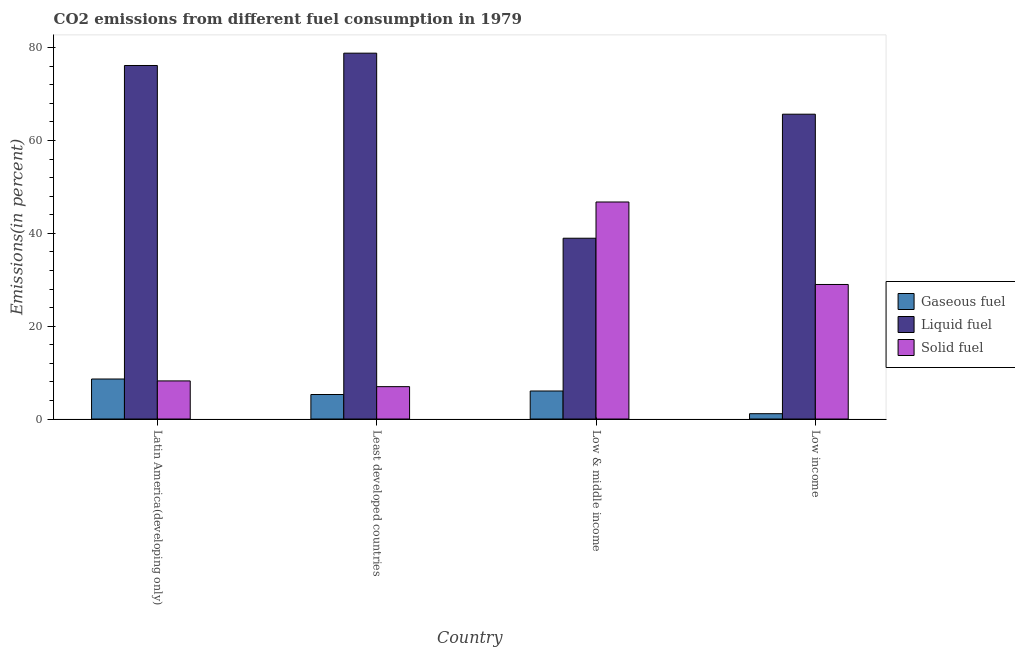How many different coloured bars are there?
Your answer should be compact. 3. How many bars are there on the 1st tick from the left?
Provide a short and direct response. 3. What is the label of the 3rd group of bars from the left?
Your answer should be compact. Low & middle income. In how many cases, is the number of bars for a given country not equal to the number of legend labels?
Keep it short and to the point. 0. What is the percentage of solid fuel emission in Low & middle income?
Your answer should be very brief. 46.75. Across all countries, what is the maximum percentage of gaseous fuel emission?
Make the answer very short. 8.62. Across all countries, what is the minimum percentage of gaseous fuel emission?
Offer a terse response. 1.15. In which country was the percentage of gaseous fuel emission maximum?
Provide a short and direct response. Latin America(developing only). What is the total percentage of gaseous fuel emission in the graph?
Your response must be concise. 21.08. What is the difference between the percentage of liquid fuel emission in Latin America(developing only) and that in Low & middle income?
Keep it short and to the point. 37.21. What is the difference between the percentage of solid fuel emission in Low income and the percentage of liquid fuel emission in Least developed countries?
Ensure brevity in your answer.  -49.83. What is the average percentage of gaseous fuel emission per country?
Ensure brevity in your answer.  5.27. What is the difference between the percentage of gaseous fuel emission and percentage of liquid fuel emission in Least developed countries?
Your response must be concise. -73.54. What is the ratio of the percentage of liquid fuel emission in Latin America(developing only) to that in Low income?
Give a very brief answer. 1.16. Is the difference between the percentage of solid fuel emission in Latin America(developing only) and Least developed countries greater than the difference between the percentage of gaseous fuel emission in Latin America(developing only) and Least developed countries?
Provide a short and direct response. No. What is the difference between the highest and the second highest percentage of liquid fuel emission?
Your answer should be very brief. 2.65. What is the difference between the highest and the lowest percentage of solid fuel emission?
Provide a short and direct response. 39.78. Is the sum of the percentage of liquid fuel emission in Latin America(developing only) and Least developed countries greater than the maximum percentage of gaseous fuel emission across all countries?
Your answer should be very brief. Yes. What does the 2nd bar from the left in Low income represents?
Your answer should be compact. Liquid fuel. What does the 1st bar from the right in Least developed countries represents?
Your response must be concise. Solid fuel. Is it the case that in every country, the sum of the percentage of gaseous fuel emission and percentage of liquid fuel emission is greater than the percentage of solid fuel emission?
Give a very brief answer. No. Are all the bars in the graph horizontal?
Your answer should be compact. No. How many countries are there in the graph?
Ensure brevity in your answer.  4. Where does the legend appear in the graph?
Your answer should be compact. Center right. How are the legend labels stacked?
Provide a short and direct response. Vertical. What is the title of the graph?
Give a very brief answer. CO2 emissions from different fuel consumption in 1979. Does "Communicable diseases" appear as one of the legend labels in the graph?
Your answer should be very brief. No. What is the label or title of the Y-axis?
Offer a terse response. Emissions(in percent). What is the Emissions(in percent) of Gaseous fuel in Latin America(developing only)?
Give a very brief answer. 8.62. What is the Emissions(in percent) in Liquid fuel in Latin America(developing only)?
Provide a succinct answer. 76.16. What is the Emissions(in percent) in Solid fuel in Latin America(developing only)?
Your response must be concise. 8.21. What is the Emissions(in percent) in Gaseous fuel in Least developed countries?
Provide a short and direct response. 5.28. What is the Emissions(in percent) of Liquid fuel in Least developed countries?
Provide a short and direct response. 78.81. What is the Emissions(in percent) of Solid fuel in Least developed countries?
Provide a succinct answer. 6.97. What is the Emissions(in percent) of Gaseous fuel in Low & middle income?
Provide a succinct answer. 6.04. What is the Emissions(in percent) of Liquid fuel in Low & middle income?
Provide a short and direct response. 38.95. What is the Emissions(in percent) of Solid fuel in Low & middle income?
Offer a terse response. 46.75. What is the Emissions(in percent) of Gaseous fuel in Low income?
Offer a terse response. 1.15. What is the Emissions(in percent) in Liquid fuel in Low income?
Provide a succinct answer. 65.67. What is the Emissions(in percent) in Solid fuel in Low income?
Offer a terse response. 28.98. Across all countries, what is the maximum Emissions(in percent) in Gaseous fuel?
Keep it short and to the point. 8.62. Across all countries, what is the maximum Emissions(in percent) in Liquid fuel?
Give a very brief answer. 78.81. Across all countries, what is the maximum Emissions(in percent) of Solid fuel?
Your response must be concise. 46.75. Across all countries, what is the minimum Emissions(in percent) in Gaseous fuel?
Provide a short and direct response. 1.15. Across all countries, what is the minimum Emissions(in percent) in Liquid fuel?
Your answer should be very brief. 38.95. Across all countries, what is the minimum Emissions(in percent) of Solid fuel?
Provide a succinct answer. 6.97. What is the total Emissions(in percent) in Gaseous fuel in the graph?
Provide a short and direct response. 21.08. What is the total Emissions(in percent) in Liquid fuel in the graph?
Provide a short and direct response. 259.59. What is the total Emissions(in percent) in Solid fuel in the graph?
Provide a short and direct response. 90.92. What is the difference between the Emissions(in percent) in Gaseous fuel in Latin America(developing only) and that in Least developed countries?
Keep it short and to the point. 3.34. What is the difference between the Emissions(in percent) in Liquid fuel in Latin America(developing only) and that in Least developed countries?
Your answer should be compact. -2.65. What is the difference between the Emissions(in percent) in Solid fuel in Latin America(developing only) and that in Least developed countries?
Offer a terse response. 1.24. What is the difference between the Emissions(in percent) in Gaseous fuel in Latin America(developing only) and that in Low & middle income?
Keep it short and to the point. 2.58. What is the difference between the Emissions(in percent) in Liquid fuel in Latin America(developing only) and that in Low & middle income?
Provide a short and direct response. 37.21. What is the difference between the Emissions(in percent) of Solid fuel in Latin America(developing only) and that in Low & middle income?
Ensure brevity in your answer.  -38.55. What is the difference between the Emissions(in percent) in Gaseous fuel in Latin America(developing only) and that in Low income?
Your answer should be compact. 7.47. What is the difference between the Emissions(in percent) of Liquid fuel in Latin America(developing only) and that in Low income?
Your answer should be compact. 10.49. What is the difference between the Emissions(in percent) of Solid fuel in Latin America(developing only) and that in Low income?
Keep it short and to the point. -20.77. What is the difference between the Emissions(in percent) in Gaseous fuel in Least developed countries and that in Low & middle income?
Keep it short and to the point. -0.76. What is the difference between the Emissions(in percent) of Liquid fuel in Least developed countries and that in Low & middle income?
Your answer should be compact. 39.87. What is the difference between the Emissions(in percent) in Solid fuel in Least developed countries and that in Low & middle income?
Give a very brief answer. -39.78. What is the difference between the Emissions(in percent) in Gaseous fuel in Least developed countries and that in Low income?
Your response must be concise. 4.13. What is the difference between the Emissions(in percent) in Liquid fuel in Least developed countries and that in Low income?
Your response must be concise. 13.15. What is the difference between the Emissions(in percent) in Solid fuel in Least developed countries and that in Low income?
Offer a terse response. -22.01. What is the difference between the Emissions(in percent) of Gaseous fuel in Low & middle income and that in Low income?
Make the answer very short. 4.89. What is the difference between the Emissions(in percent) in Liquid fuel in Low & middle income and that in Low income?
Give a very brief answer. -26.72. What is the difference between the Emissions(in percent) of Solid fuel in Low & middle income and that in Low income?
Your answer should be compact. 17.77. What is the difference between the Emissions(in percent) in Gaseous fuel in Latin America(developing only) and the Emissions(in percent) in Liquid fuel in Least developed countries?
Your answer should be very brief. -70.2. What is the difference between the Emissions(in percent) of Gaseous fuel in Latin America(developing only) and the Emissions(in percent) of Solid fuel in Least developed countries?
Ensure brevity in your answer.  1.65. What is the difference between the Emissions(in percent) in Liquid fuel in Latin America(developing only) and the Emissions(in percent) in Solid fuel in Least developed countries?
Your answer should be very brief. 69.19. What is the difference between the Emissions(in percent) in Gaseous fuel in Latin America(developing only) and the Emissions(in percent) in Liquid fuel in Low & middle income?
Your answer should be compact. -30.33. What is the difference between the Emissions(in percent) in Gaseous fuel in Latin America(developing only) and the Emissions(in percent) in Solid fuel in Low & middle income?
Your answer should be compact. -38.14. What is the difference between the Emissions(in percent) of Liquid fuel in Latin America(developing only) and the Emissions(in percent) of Solid fuel in Low & middle income?
Provide a short and direct response. 29.41. What is the difference between the Emissions(in percent) of Gaseous fuel in Latin America(developing only) and the Emissions(in percent) of Liquid fuel in Low income?
Your answer should be compact. -57.05. What is the difference between the Emissions(in percent) of Gaseous fuel in Latin America(developing only) and the Emissions(in percent) of Solid fuel in Low income?
Keep it short and to the point. -20.37. What is the difference between the Emissions(in percent) in Liquid fuel in Latin America(developing only) and the Emissions(in percent) in Solid fuel in Low income?
Keep it short and to the point. 47.18. What is the difference between the Emissions(in percent) in Gaseous fuel in Least developed countries and the Emissions(in percent) in Liquid fuel in Low & middle income?
Your response must be concise. -33.67. What is the difference between the Emissions(in percent) in Gaseous fuel in Least developed countries and the Emissions(in percent) in Solid fuel in Low & middle income?
Give a very brief answer. -41.48. What is the difference between the Emissions(in percent) of Liquid fuel in Least developed countries and the Emissions(in percent) of Solid fuel in Low & middle income?
Make the answer very short. 32.06. What is the difference between the Emissions(in percent) in Gaseous fuel in Least developed countries and the Emissions(in percent) in Liquid fuel in Low income?
Make the answer very short. -60.39. What is the difference between the Emissions(in percent) of Gaseous fuel in Least developed countries and the Emissions(in percent) of Solid fuel in Low income?
Your answer should be very brief. -23.71. What is the difference between the Emissions(in percent) in Liquid fuel in Least developed countries and the Emissions(in percent) in Solid fuel in Low income?
Keep it short and to the point. 49.83. What is the difference between the Emissions(in percent) of Gaseous fuel in Low & middle income and the Emissions(in percent) of Liquid fuel in Low income?
Offer a terse response. -59.63. What is the difference between the Emissions(in percent) in Gaseous fuel in Low & middle income and the Emissions(in percent) in Solid fuel in Low income?
Make the answer very short. -22.95. What is the difference between the Emissions(in percent) of Liquid fuel in Low & middle income and the Emissions(in percent) of Solid fuel in Low income?
Provide a short and direct response. 9.96. What is the average Emissions(in percent) in Gaseous fuel per country?
Give a very brief answer. 5.27. What is the average Emissions(in percent) of Liquid fuel per country?
Make the answer very short. 64.9. What is the average Emissions(in percent) of Solid fuel per country?
Your answer should be compact. 22.73. What is the difference between the Emissions(in percent) in Gaseous fuel and Emissions(in percent) in Liquid fuel in Latin America(developing only)?
Keep it short and to the point. -67.54. What is the difference between the Emissions(in percent) of Gaseous fuel and Emissions(in percent) of Solid fuel in Latin America(developing only)?
Provide a short and direct response. 0.41. What is the difference between the Emissions(in percent) of Liquid fuel and Emissions(in percent) of Solid fuel in Latin America(developing only)?
Provide a short and direct response. 67.95. What is the difference between the Emissions(in percent) of Gaseous fuel and Emissions(in percent) of Liquid fuel in Least developed countries?
Provide a succinct answer. -73.54. What is the difference between the Emissions(in percent) in Gaseous fuel and Emissions(in percent) in Solid fuel in Least developed countries?
Provide a succinct answer. -1.69. What is the difference between the Emissions(in percent) of Liquid fuel and Emissions(in percent) of Solid fuel in Least developed countries?
Give a very brief answer. 71.84. What is the difference between the Emissions(in percent) of Gaseous fuel and Emissions(in percent) of Liquid fuel in Low & middle income?
Your answer should be very brief. -32.91. What is the difference between the Emissions(in percent) of Gaseous fuel and Emissions(in percent) of Solid fuel in Low & middle income?
Make the answer very short. -40.72. What is the difference between the Emissions(in percent) of Liquid fuel and Emissions(in percent) of Solid fuel in Low & middle income?
Offer a very short reply. -7.81. What is the difference between the Emissions(in percent) of Gaseous fuel and Emissions(in percent) of Liquid fuel in Low income?
Make the answer very short. -64.52. What is the difference between the Emissions(in percent) in Gaseous fuel and Emissions(in percent) in Solid fuel in Low income?
Your answer should be compact. -27.84. What is the difference between the Emissions(in percent) in Liquid fuel and Emissions(in percent) in Solid fuel in Low income?
Your answer should be very brief. 36.68. What is the ratio of the Emissions(in percent) in Gaseous fuel in Latin America(developing only) to that in Least developed countries?
Keep it short and to the point. 1.63. What is the ratio of the Emissions(in percent) of Liquid fuel in Latin America(developing only) to that in Least developed countries?
Give a very brief answer. 0.97. What is the ratio of the Emissions(in percent) of Solid fuel in Latin America(developing only) to that in Least developed countries?
Keep it short and to the point. 1.18. What is the ratio of the Emissions(in percent) of Gaseous fuel in Latin America(developing only) to that in Low & middle income?
Your response must be concise. 1.43. What is the ratio of the Emissions(in percent) in Liquid fuel in Latin America(developing only) to that in Low & middle income?
Keep it short and to the point. 1.96. What is the ratio of the Emissions(in percent) of Solid fuel in Latin America(developing only) to that in Low & middle income?
Offer a very short reply. 0.18. What is the ratio of the Emissions(in percent) in Gaseous fuel in Latin America(developing only) to that in Low income?
Give a very brief answer. 7.51. What is the ratio of the Emissions(in percent) of Liquid fuel in Latin America(developing only) to that in Low income?
Provide a succinct answer. 1.16. What is the ratio of the Emissions(in percent) in Solid fuel in Latin America(developing only) to that in Low income?
Keep it short and to the point. 0.28. What is the ratio of the Emissions(in percent) in Gaseous fuel in Least developed countries to that in Low & middle income?
Your answer should be very brief. 0.87. What is the ratio of the Emissions(in percent) in Liquid fuel in Least developed countries to that in Low & middle income?
Give a very brief answer. 2.02. What is the ratio of the Emissions(in percent) in Solid fuel in Least developed countries to that in Low & middle income?
Your answer should be compact. 0.15. What is the ratio of the Emissions(in percent) of Gaseous fuel in Least developed countries to that in Low income?
Give a very brief answer. 4.6. What is the ratio of the Emissions(in percent) of Liquid fuel in Least developed countries to that in Low income?
Make the answer very short. 1.2. What is the ratio of the Emissions(in percent) of Solid fuel in Least developed countries to that in Low income?
Ensure brevity in your answer.  0.24. What is the ratio of the Emissions(in percent) in Gaseous fuel in Low & middle income to that in Low income?
Your answer should be compact. 5.26. What is the ratio of the Emissions(in percent) in Liquid fuel in Low & middle income to that in Low income?
Your answer should be very brief. 0.59. What is the ratio of the Emissions(in percent) of Solid fuel in Low & middle income to that in Low income?
Offer a terse response. 1.61. What is the difference between the highest and the second highest Emissions(in percent) of Gaseous fuel?
Your answer should be compact. 2.58. What is the difference between the highest and the second highest Emissions(in percent) in Liquid fuel?
Offer a terse response. 2.65. What is the difference between the highest and the second highest Emissions(in percent) in Solid fuel?
Keep it short and to the point. 17.77. What is the difference between the highest and the lowest Emissions(in percent) in Gaseous fuel?
Make the answer very short. 7.47. What is the difference between the highest and the lowest Emissions(in percent) of Liquid fuel?
Your response must be concise. 39.87. What is the difference between the highest and the lowest Emissions(in percent) of Solid fuel?
Your answer should be compact. 39.78. 